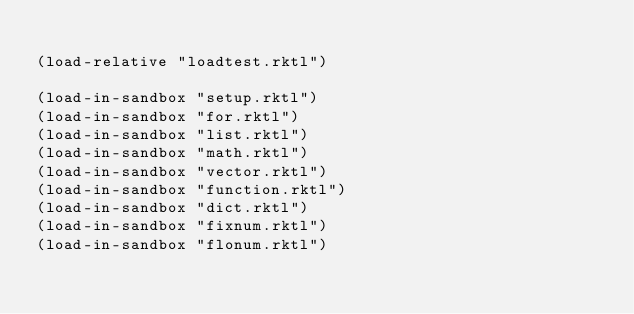<code> <loc_0><loc_0><loc_500><loc_500><_Racket_>
(load-relative "loadtest.rktl")

(load-in-sandbox "setup.rktl")
(load-in-sandbox "for.rktl")
(load-in-sandbox "list.rktl")
(load-in-sandbox "math.rktl")
(load-in-sandbox "vector.rktl")
(load-in-sandbox "function.rktl")
(load-in-sandbox "dict.rktl")
(load-in-sandbox "fixnum.rktl")
(load-in-sandbox "flonum.rktl")

</code> 